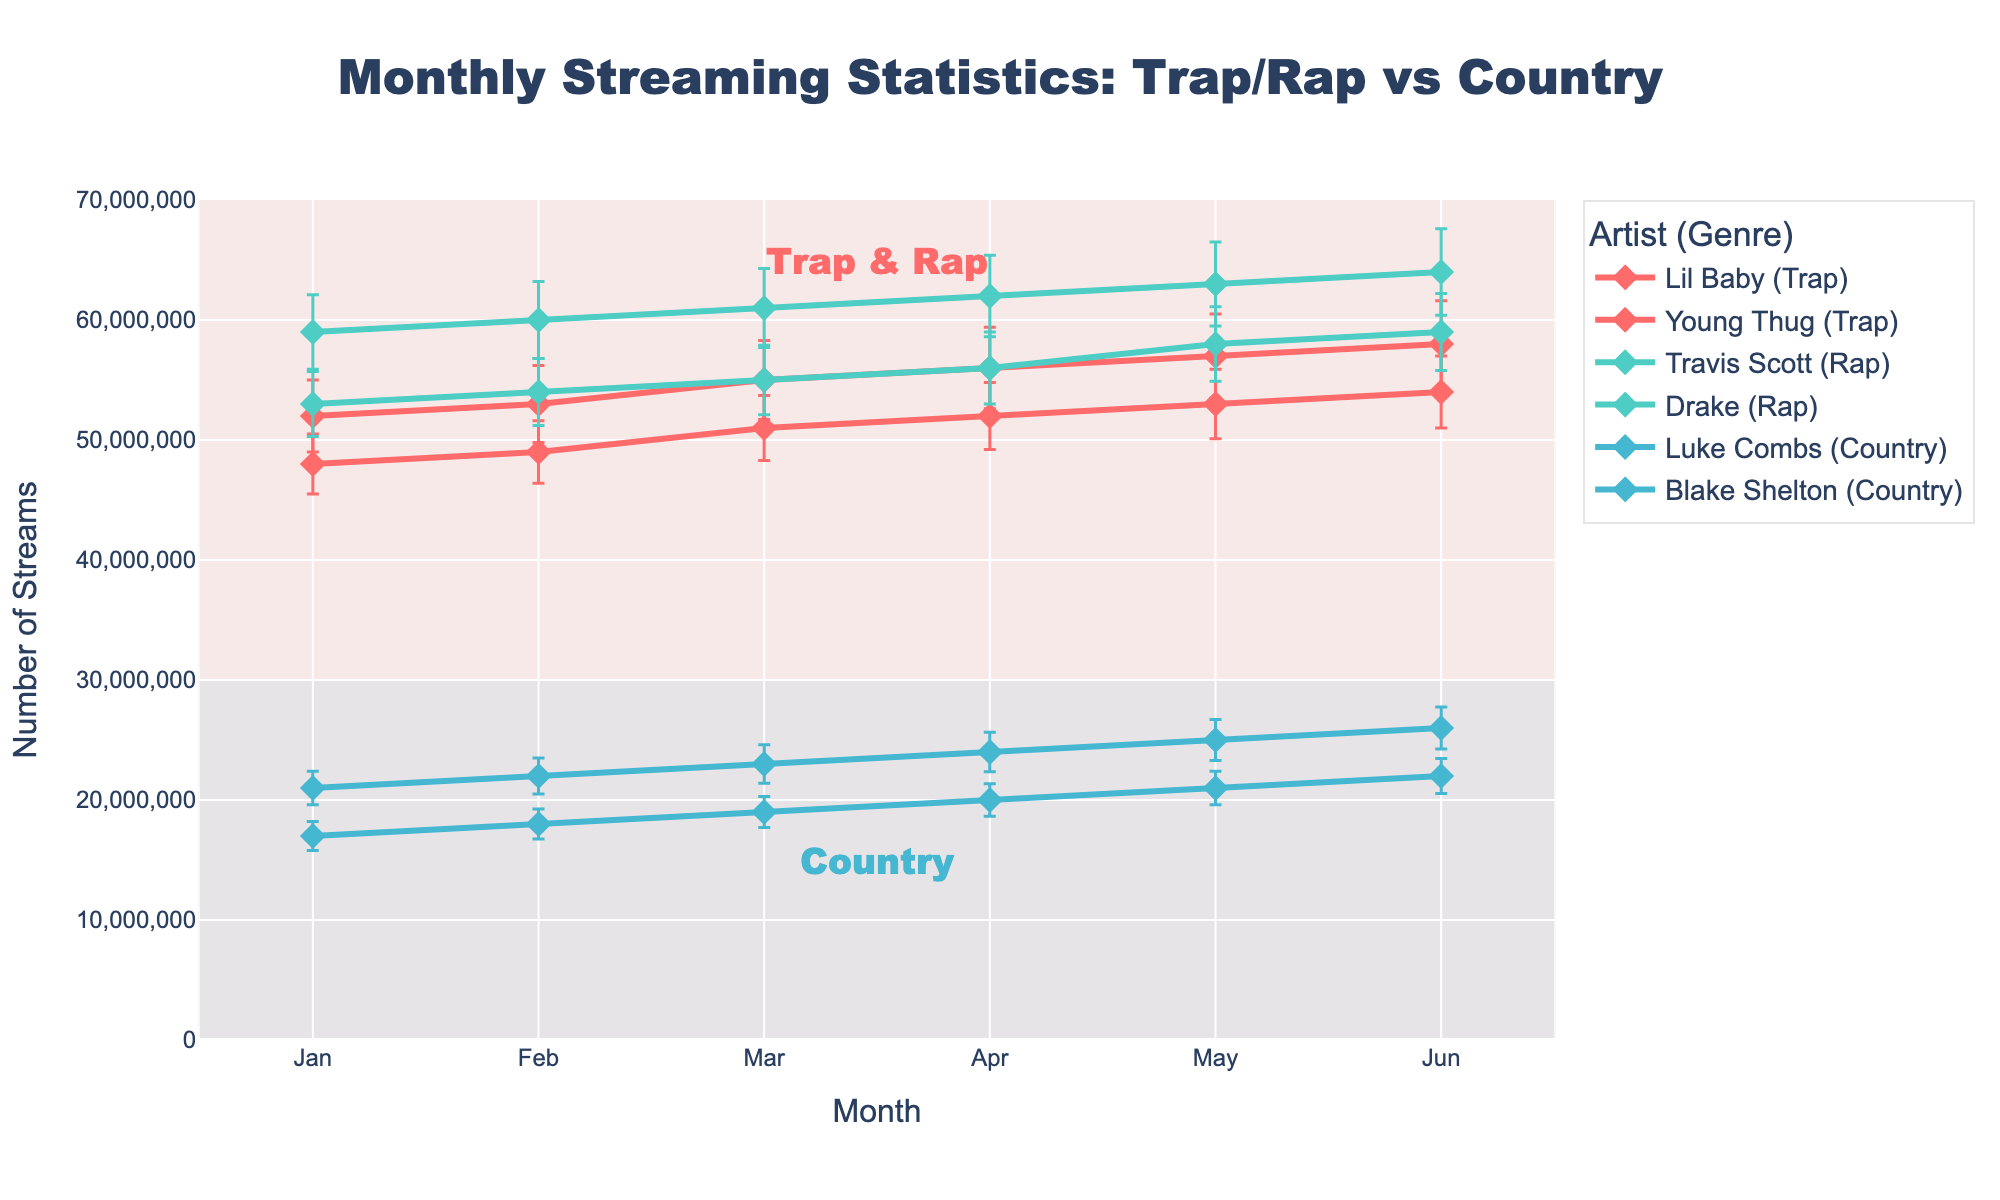When is the highest streaming count observed for Drake and what is the value? Look at the line corresponding to Drake. The highest point in this line is in June with the highest count value.
Answer: June, 64 million What does the title of the plot say? Refer directly to the text at the top center of the figure; it's set up to summarize the content of the plot.
Answer: Monthly Streaming Statistics: Trap/Rap vs Country How do the streaming statistics for Luke Combs in April compare to January? Identify the data points for Luke Combs in both months. Subtract the number in January from April to find out the difference.
Answer: +3 million Which artist has the most variability in streaming numbers, and how can you tell? Examine the lengths of the error bars for each artist. The artist with the longest error bars indicates the most variability.
Answer: Lil Baby Between Lil Baby and Luke Combs, who had higher streaming numbers, on average, in June? Compare the height of the points for both artists in June. Lil Baby is higher on the y-axis.
Answer: Lil Baby What is the approximate average monthly increase in streams for Travis Scott from January to June? Subtract the January value from the June value, then divide by the number of months (5).
Answer: 1.2 million per month Which genre shows more consistent streaming numbers over the months, and why? Consistency can be judged by the error bars. Country shows short error bars, indicating less variability compared to Trap and Rap.
Answer: Country What is the difference between the highest value for Travis Scott in June and the lowest value for Blake Shelton in January? Identify and subtract Blake Shelton's lowest value from Travis Scott's highest. 59 million - 17 million.
Answer: 42 million Who saw the largest increase in streaming numbers from May to June? Compare changes in heights of the points for each artist between these months. Lil Baby shows the largest increase.
Answer: Lil Baby How do the error bars for Drake in February compare to those for Young Thug in May? Compare the vertical lines attached to the points for both artists in these months. Drake's error bars appear longer.
Answer: Drake has longer error bars 